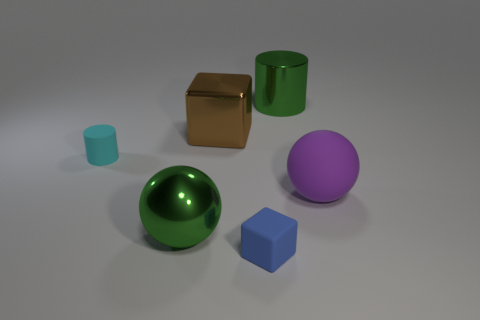Add 3 green things. How many objects exist? 9 Subtract all blocks. How many objects are left? 4 Subtract all blue blocks. Subtract all small rubber objects. How many objects are left? 3 Add 6 small cyan matte things. How many small cyan matte things are left? 7 Add 5 large green objects. How many large green objects exist? 7 Subtract 0 purple cylinders. How many objects are left? 6 